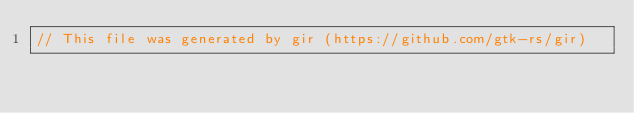Convert code to text. <code><loc_0><loc_0><loc_500><loc_500><_Rust_>// This file was generated by gir (https://github.com/gtk-rs/gir)</code> 